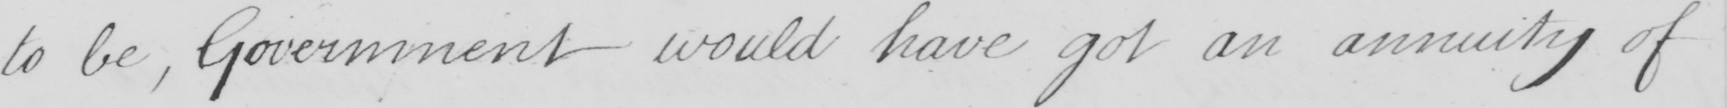Transcribe the text shown in this historical manuscript line. to be , Government would have got an annuity of 